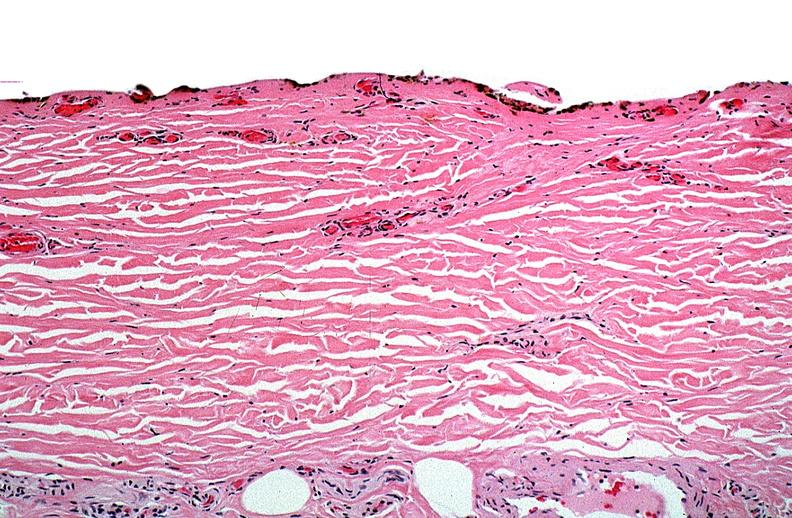where is this?
Answer the question using a single word or phrase. Skin 